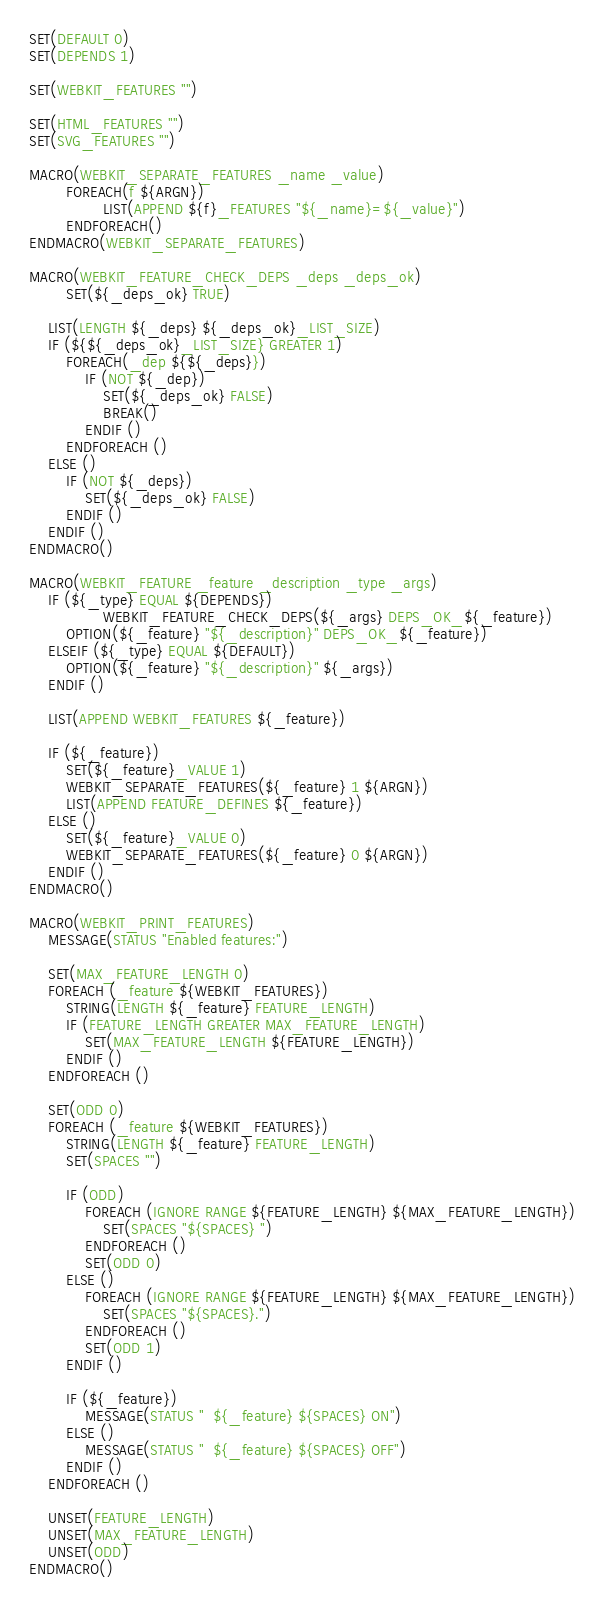<code> <loc_0><loc_0><loc_500><loc_500><_CMake_>SET(DEFAULT 0)
SET(DEPENDS 1)

SET(WEBKIT_FEATURES "")

SET(HTML_FEATURES "")
SET(SVG_FEATURES "")

MACRO(WEBKIT_SEPARATE_FEATURES _name _value)
        FOREACH(f ${ARGN})
                LIST(APPEND ${f}_FEATURES "${_name}=${_value}")
        ENDFOREACH()
ENDMACRO(WEBKIT_SEPARATE_FEATURES)

MACRO(WEBKIT_FEATURE_CHECK_DEPS _deps _deps_ok)
        SET(${_deps_ok} TRUE)

	LIST(LENGTH ${_deps} ${_deps_ok}_LIST_SIZE)
	IF (${${_deps_ok}_LIST_SIZE} GREATER 1)
		FOREACH(_dep ${${_deps}})
			IF (NOT ${_dep})
				SET(${_deps_ok} FALSE)
				BREAK()
			ENDIF ()
		ENDFOREACH ()
	ELSE ()
		IF (NOT ${_deps})
			SET(${_deps_ok} FALSE)
		ENDIF ()
	ENDIF ()
ENDMACRO()

MACRO(WEBKIT_FEATURE _feature _description _type _args)
	IF (${_type} EQUAL ${DEPENDS})
                WEBKIT_FEATURE_CHECK_DEPS(${_args} DEPS_OK_${_feature})
		OPTION(${_feature} "${_description}" DEPS_OK_${_feature})
	ELSEIF (${_type} EQUAL ${DEFAULT})
		OPTION(${_feature} "${_description}" ${_args})
	ENDIF ()
	
	LIST(APPEND WEBKIT_FEATURES ${_feature})

	IF (${_feature})
		SET(${_feature}_VALUE 1)
		WEBKIT_SEPARATE_FEATURES(${_feature} 1 ${ARGN})
		LIST(APPEND FEATURE_DEFINES ${_feature})
	ELSE ()
		SET(${_feature}_VALUE 0)
		WEBKIT_SEPARATE_FEATURES(${_feature} 0 ${ARGN})
	ENDIF ()
ENDMACRO()

MACRO(WEBKIT_PRINT_FEATURES)
	MESSAGE(STATUS "Enabled features:")

	SET(MAX_FEATURE_LENGTH 0)
	FOREACH (_feature ${WEBKIT_FEATURES})
		STRING(LENGTH ${_feature} FEATURE_LENGTH)
		IF (FEATURE_LENGTH GREATER MAX_FEATURE_LENGTH)
			SET(MAX_FEATURE_LENGTH ${FEATURE_LENGTH})
		ENDIF ()
	ENDFOREACH ()

	SET(ODD 0)
	FOREACH (_feature ${WEBKIT_FEATURES})
		STRING(LENGTH ${_feature} FEATURE_LENGTH)
		SET(SPACES "")

		IF (ODD)
			FOREACH (IGNORE RANGE ${FEATURE_LENGTH} ${MAX_FEATURE_LENGTH})
				SET(SPACES "${SPACES} ")
			ENDFOREACH ()
			SET(ODD 0)
		ELSE ()
			FOREACH (IGNORE RANGE ${FEATURE_LENGTH} ${MAX_FEATURE_LENGTH})
				SET(SPACES "${SPACES}.")
			ENDFOREACH ()
			SET(ODD 1)
		ENDIF ()

		IF (${_feature})
			MESSAGE(STATUS "  ${_feature} ${SPACES} ON")
		ELSE ()
			MESSAGE(STATUS "  ${_feature} ${SPACES} OFF")
		ENDIF ()
	ENDFOREACH ()

	UNSET(FEATURE_LENGTH)
	UNSET(MAX_FEATURE_LENGTH)
	UNSET(ODD)
ENDMACRO()
</code> 